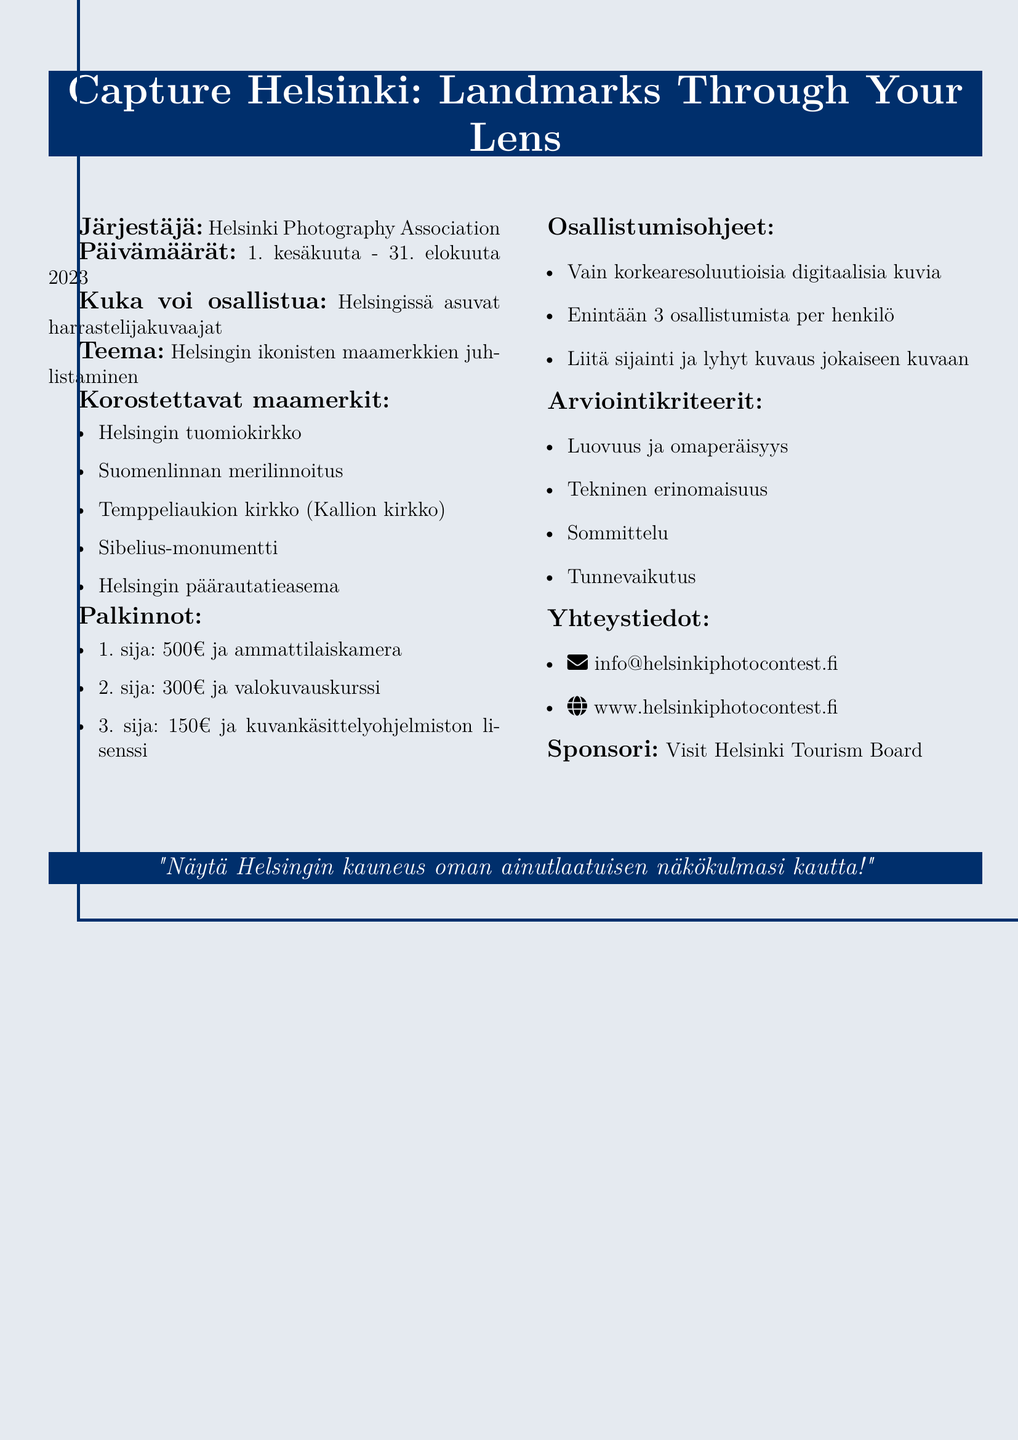What is the contest name? The contest name is explicitly stated in the document as the main title, "Capture Helsinki: Landmarks Through Your Lens."
Answer: Capture Helsinki: Landmarks Through Your Lens Who is the organizer of the contest? The organizer's name is mentioned in the document under the organizer section, identifying the Helsinki Photography Association.
Answer: Helsinki Photography Association What is the prize for the 1st place winner? The prize details for the 1st place winner, including the amount of money and the item, are listed under the prizes section in the document.
Answer: €500 and a professional camera How many entries can each participant submit? The document specifies that a maximum of 3 entries are allowed per participant, which is stated in the submission guidelines.
Answer: 3 What are the judging criteria? The criteria for judging are listed as a series of bullet points, indicating the different factors considered in the evaluation process.
Answer: Creativity and originality, Technical excellence, Composition, Emotional impact What are the featured landmarks in the contest? The landmarks are enumerated in a list format, detailing the specific locations that participants should focus on for their photographs.
Answer: Helsinki Cathedral, Suomenlinna Sea Fortress, Temppeliaukio Church, Sibelius Monument, Helsinki Central Railway Station What are the contest dates? The dates when the contest runs are provided clearly in the document, specifying from when to when the contest will take place.
Answer: June 1 - August 31, 2023 Who is the sponsor of the contest? The sponsor of the contest is explicitly mentioned at the bottom of the document, identifying the associated tourism board.
Answer: Visit Helsinki Tourism Board What is the contact email for inquiries? The contact email provided in the document allows participants to reach out for further information regarding the contest.
Answer: info@helsinkiphotocontest.fi 